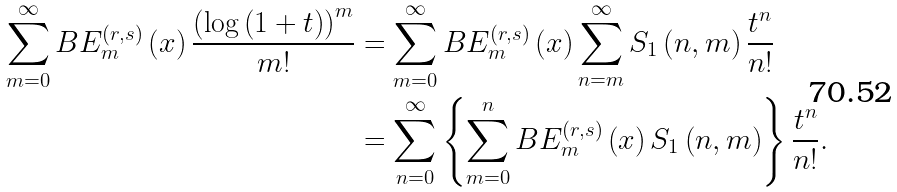<formula> <loc_0><loc_0><loc_500><loc_500>\sum _ { m = 0 } ^ { \infty } B E _ { m } ^ { \left ( r , s \right ) } \left ( x \right ) \frac { \left ( \log \left ( 1 + t \right ) \right ) ^ { m } } { m ! } & = \sum _ { m = 0 } ^ { \infty } B E _ { m } ^ { \left ( r , s \right ) } \left ( x \right ) \sum _ { n = m } ^ { \infty } S _ { 1 } \left ( n , m \right ) \frac { t ^ { n } } { n ! } \\ & = \sum _ { n = 0 } ^ { \infty } \left \{ \sum _ { m = 0 } ^ { n } B E _ { m } ^ { \left ( r , s \right ) } \left ( x \right ) S _ { 1 } \left ( n , m \right ) \right \} \frac { t ^ { n } } { n ! } .</formula> 